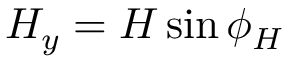<formula> <loc_0><loc_0><loc_500><loc_500>H _ { y } = H \sin { \phi _ { H } }</formula> 